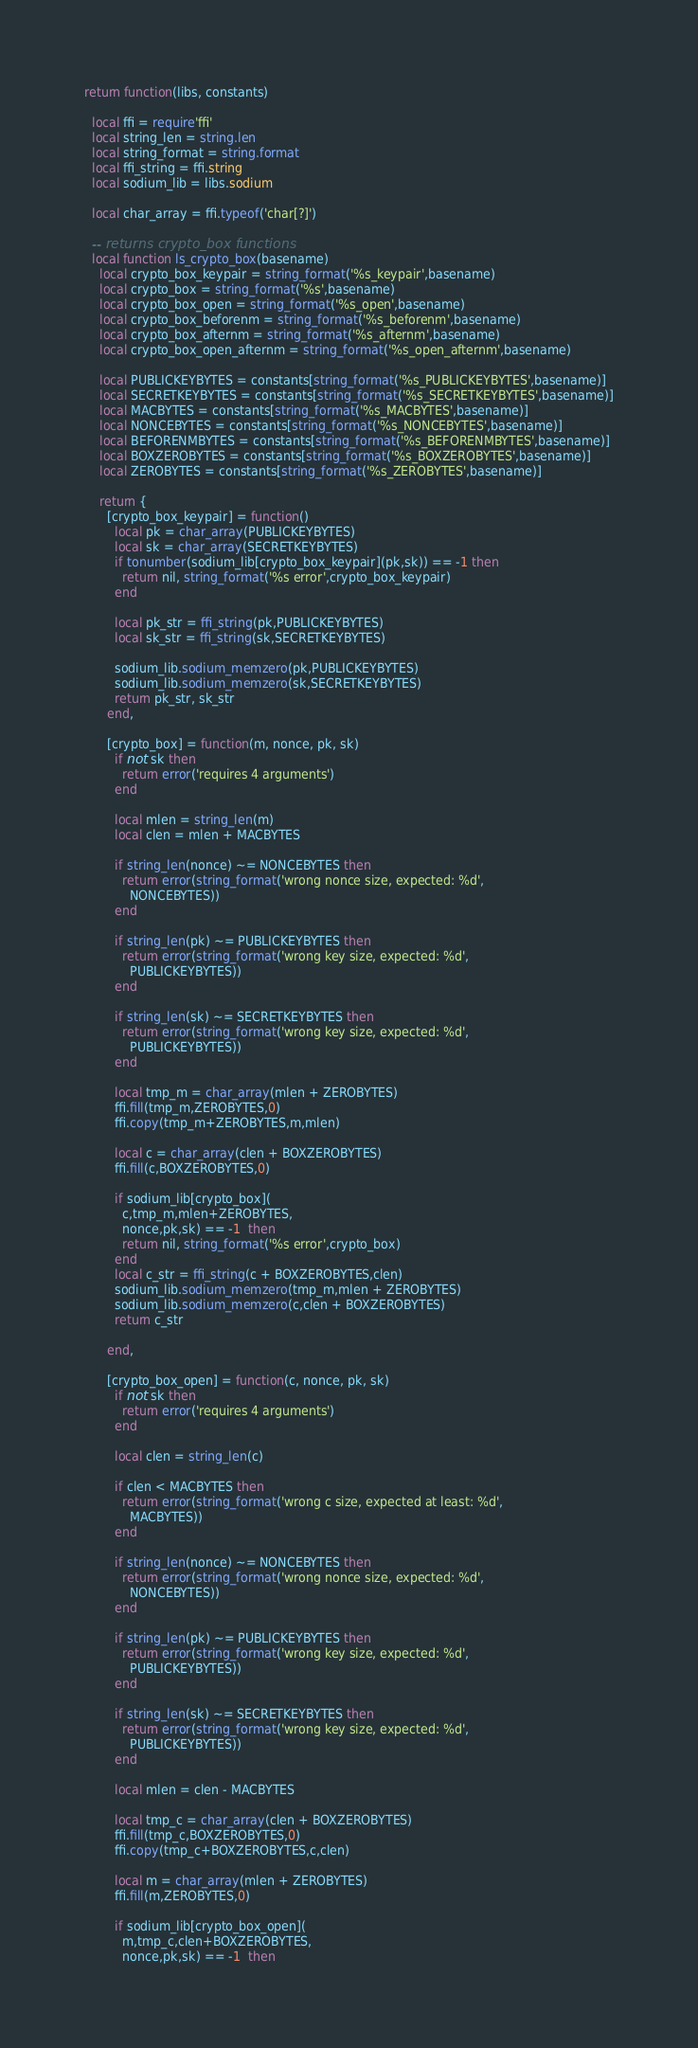<code> <loc_0><loc_0><loc_500><loc_500><_Lua_>return function(libs, constants)

  local ffi = require'ffi'
  local string_len = string.len
  local string_format = string.format
  local ffi_string = ffi.string
  local sodium_lib = libs.sodium

  local char_array = ffi.typeof('char[?]')

  -- returns crypto_box functions
  local function ls_crypto_box(basename)
    local crypto_box_keypair = string_format('%s_keypair',basename)
    local crypto_box = string_format('%s',basename)
    local crypto_box_open = string_format('%s_open',basename)
    local crypto_box_beforenm = string_format('%s_beforenm',basename)
    local crypto_box_afternm = string_format('%s_afternm',basename)
    local crypto_box_open_afternm = string_format('%s_open_afternm',basename)

    local PUBLICKEYBYTES = constants[string_format('%s_PUBLICKEYBYTES',basename)]
    local SECRETKEYBYTES = constants[string_format('%s_SECRETKEYBYTES',basename)]
    local MACBYTES = constants[string_format('%s_MACBYTES',basename)]
    local NONCEBYTES = constants[string_format('%s_NONCEBYTES',basename)]
    local BEFORENMBYTES = constants[string_format('%s_BEFORENMBYTES',basename)]
    local BOXZEROBYTES = constants[string_format('%s_BOXZEROBYTES',basename)]
    local ZEROBYTES = constants[string_format('%s_ZEROBYTES',basename)]

    return {
      [crypto_box_keypair] = function()
        local pk = char_array(PUBLICKEYBYTES)
        local sk = char_array(SECRETKEYBYTES)
        if tonumber(sodium_lib[crypto_box_keypair](pk,sk)) == -1 then
          return nil, string_format('%s error',crypto_box_keypair)
        end

        local pk_str = ffi_string(pk,PUBLICKEYBYTES)
        local sk_str = ffi_string(sk,SECRETKEYBYTES)

        sodium_lib.sodium_memzero(pk,PUBLICKEYBYTES)
        sodium_lib.sodium_memzero(sk,SECRETKEYBYTES)
        return pk_str, sk_str
      end,

      [crypto_box] = function(m, nonce, pk, sk)
        if not sk then
          return error('requires 4 arguments')
        end

        local mlen = string_len(m)
        local clen = mlen + MACBYTES

        if string_len(nonce) ~= NONCEBYTES then
          return error(string_format('wrong nonce size, expected: %d',
            NONCEBYTES))
        end

        if string_len(pk) ~= PUBLICKEYBYTES then
          return error(string_format('wrong key size, expected: %d',
            PUBLICKEYBYTES))
        end

        if string_len(sk) ~= SECRETKEYBYTES then
          return error(string_format('wrong key size, expected: %d',
            PUBLICKEYBYTES))
        end

        local tmp_m = char_array(mlen + ZEROBYTES)
        ffi.fill(tmp_m,ZEROBYTES,0)
        ffi.copy(tmp_m+ZEROBYTES,m,mlen)

        local c = char_array(clen + BOXZEROBYTES)
        ffi.fill(c,BOXZEROBYTES,0)

        if sodium_lib[crypto_box](
          c,tmp_m,mlen+ZEROBYTES,
          nonce,pk,sk) == -1  then
          return nil, string_format('%s error',crypto_box)
        end
        local c_str = ffi_string(c + BOXZEROBYTES,clen)
        sodium_lib.sodium_memzero(tmp_m,mlen + ZEROBYTES)
        sodium_lib.sodium_memzero(c,clen + BOXZEROBYTES)
        return c_str

      end,

      [crypto_box_open] = function(c, nonce, pk, sk)
        if not sk then
          return error('requires 4 arguments')
        end

        local clen = string_len(c)

        if clen < MACBYTES then
          return error(string_format('wrong c size, expected at least: %d',
            MACBYTES))
        end

        if string_len(nonce) ~= NONCEBYTES then
          return error(string_format('wrong nonce size, expected: %d',
            NONCEBYTES))
        end

        if string_len(pk) ~= PUBLICKEYBYTES then
          return error(string_format('wrong key size, expected: %d',
            PUBLICKEYBYTES))
        end

        if string_len(sk) ~= SECRETKEYBYTES then
          return error(string_format('wrong key size, expected: %d',
            PUBLICKEYBYTES))
        end

        local mlen = clen - MACBYTES

        local tmp_c = char_array(clen + BOXZEROBYTES)
        ffi.fill(tmp_c,BOXZEROBYTES,0)
        ffi.copy(tmp_c+BOXZEROBYTES,c,clen)

        local m = char_array(mlen + ZEROBYTES)
        ffi.fill(m,ZEROBYTES,0)

        if sodium_lib[crypto_box_open](
          m,tmp_c,clen+BOXZEROBYTES,
          nonce,pk,sk) == -1  then</code> 